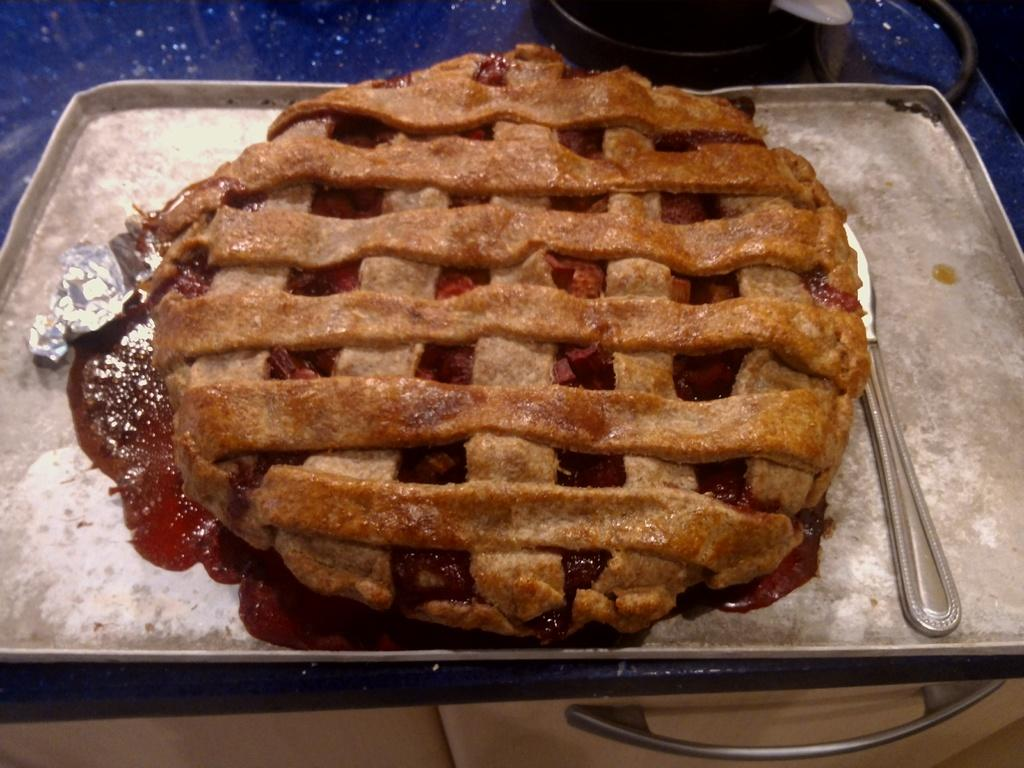What is on the iron plate in the image? There is food on an iron plate in the image. What type of sauce is present in the image? There is a sauce in red color in the image. How many yaks can be seen crossing the bridge in the image? There is no bridge or yak present in the image. What type of frog is sitting on the food in the image? There is no frog present in the image; it only features food on an iron plate and a red sauce. 